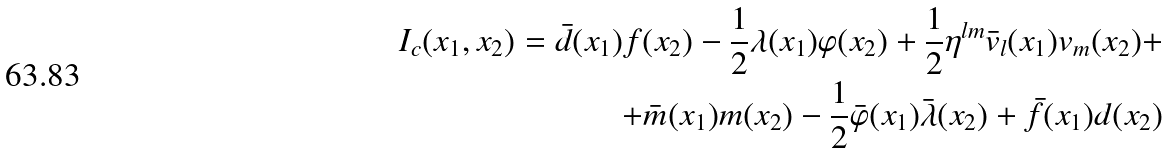<formula> <loc_0><loc_0><loc_500><loc_500>I _ { c } ( x _ { 1 } , x _ { 2 } ) = \bar { d } ( x _ { 1 } ) f ( x _ { 2 } ) - \frac { 1 } { 2 } \lambda ( x _ { 1 } ) \varphi ( x _ { 2 } ) + \frac { 1 } { 2 } \eta ^ { l m } \bar { v } _ { l } ( x _ { 1 } ) v _ { m } ( x _ { 2 } ) + \\ + \bar { m } ( x _ { 1 } ) m ( x _ { 2 } ) - \frac { 1 } { 2 } \bar { \varphi } ( x _ { 1 } ) \bar { \lambda } ( x _ { 2 } ) + \bar { f } ( x _ { 1 } ) d ( x _ { 2 } )</formula> 